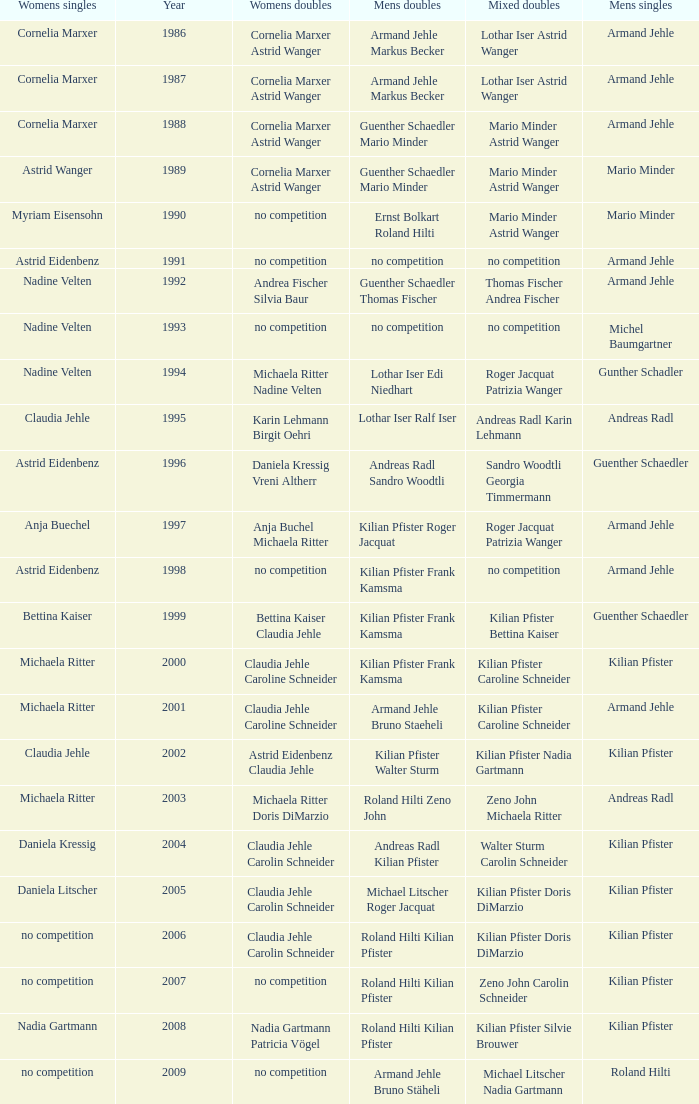In the year 2006, the womens singles had no competition and the mens doubles were roland hilti kilian pfister, what were the womens doubles Claudia Jehle Carolin Schneider. 